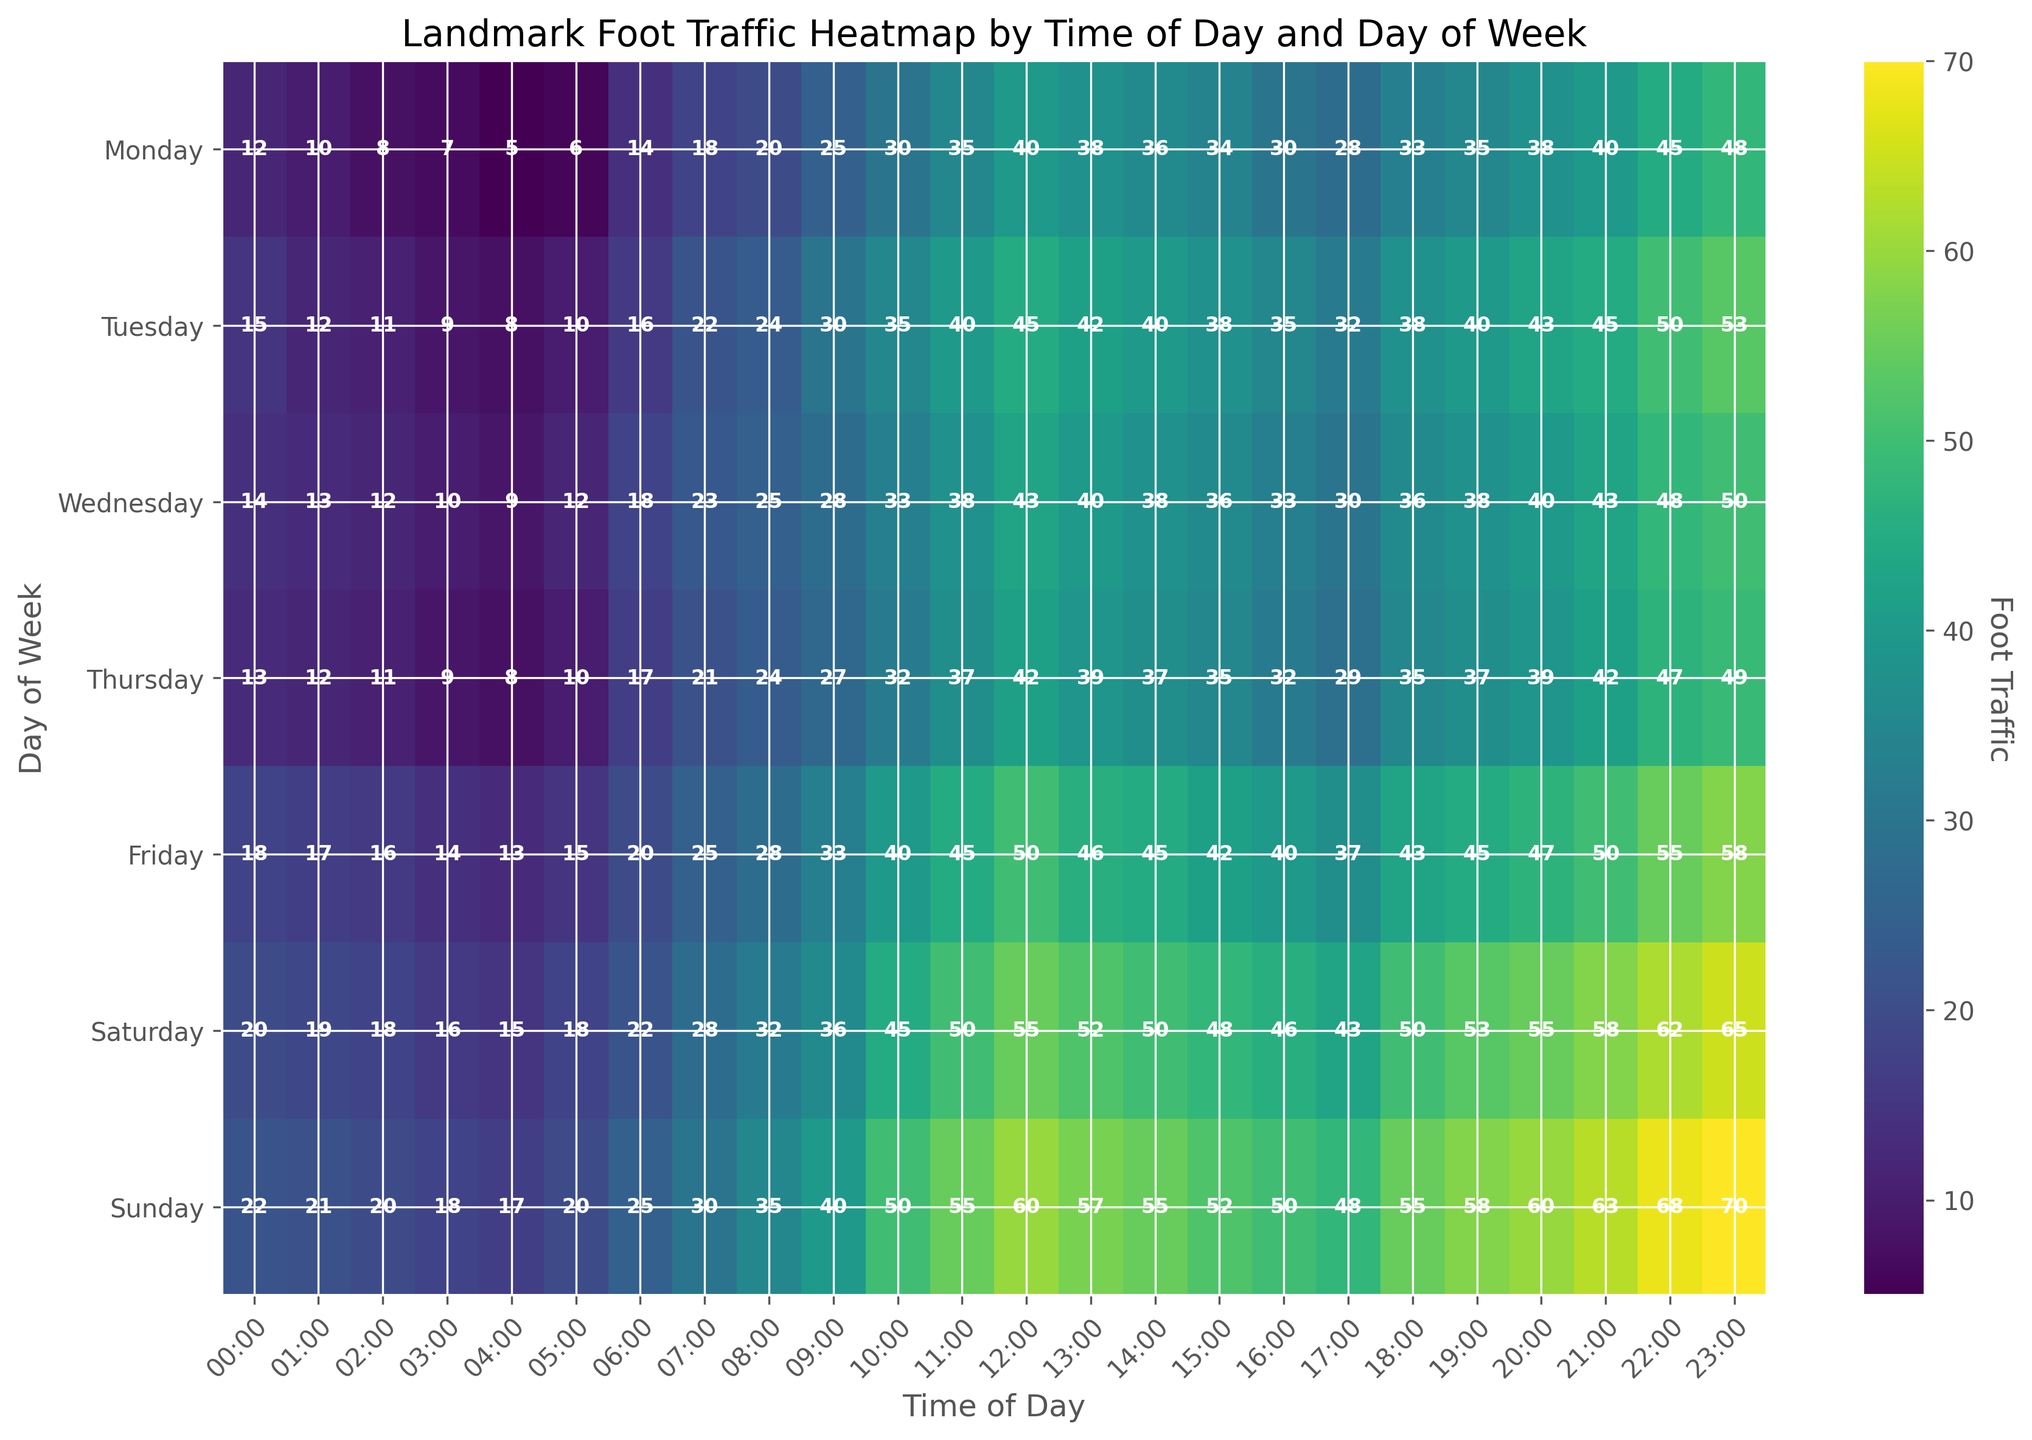How does the foot traffic at 10:00 AM on Saturday compare to the same time on Wednesday? Look at the color intensity and the data values at 10:00 AM for both Saturday and Wednesday. It shows 45 units on Saturday and 33 units on Wednesday.
Answer: Saturday has more foot traffic at 10:00 AM than Wednesday Which day of the week experiences the most foot traffic at 9:00 PM? Locate 9:00 PM on the x-axis and compare the corresponding y-values for each day of the week. Sunday has the highest foot traffic value of 63.
Answer: Sunday Is the foot traffic generally higher during the early morning hours (12:00 AM to 6:00 AM) on weekends compared to weekdays? Compare the color intensity and values for times 12:00 AM to 6:00 AM on Saturday and Sunday against those on Monday through Friday. Weekend values are generally higher.
Answer: Yes, higher on weekends What is the average foot traffic at 6:00 PM for the entire week? Find the values at 6:00 PM for each day, which are 33, 38, 36, 35, 43, 50, and 55. Sum these (33 + 38 + 36 + 35 + 43 + 50 + 55 = 290) and then divide by 7.
Answer: 41.43 During which hour on Friday does foot traffic peak? Look down the Friday column to find the hour with the highest value. The value 58 at 11:00 PM is the peak.
Answer: 11:00 PM What day has the least foot traffic at 3:00 AM? Locate 3:00 AM on the x-axis and check the corresponding y-values for each day. Monday has the lowest value of 7.
Answer: Monday How does the foot traffic change throughout the day on Thursdays? Examine the Thursday column from top to bottom. Initially low foot traffic in the early hours increases throughout the morning, peaks around midday, and gradually decreases into the night.
Answer: Increases and then decreases Which two days have the closest foot traffic values at 5:00 AM, and what are those values? Check the values at 5:00 AM: Monday (6), Tuesday (10), Wednesday (12), Thursday (10), Friday (15), Saturday (18), Sunday (20). The closest are Tuesday and Thursday, both at 10.
Answer: Tuesday and Thursday, 10 On weekends, is the foot traffic generally higher in the morning (6:00 AM - 12:00 PM) or in the evening (6:00 PM - 12:00 AM)? Compare the values for Saturday and Sunday from 6:00 AM to 12:00 PM (22, 25, 28, 32, 36, 45) to those from 6:00 PM to 12:00 AM (50, 55, 58, 63, 68, 70). The evening values are higher.
Answer: Evening What is the difference in foot traffic between Monday and Friday at 2:00 PM? Look at the 2:00 PM values for Monday (36) and Friday (45), then subtract: 45 - 36.
Answer: 9 